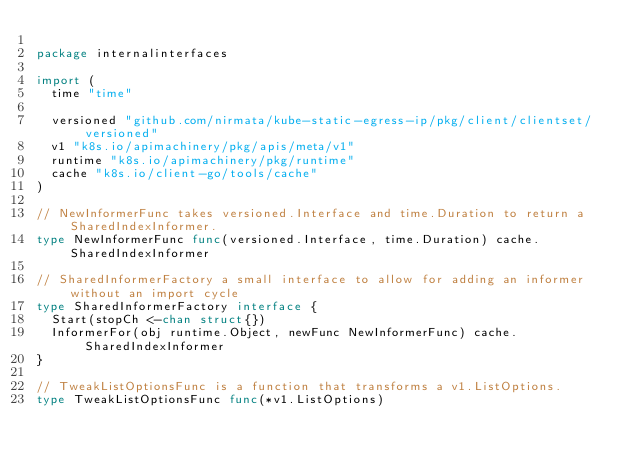Convert code to text. <code><loc_0><loc_0><loc_500><loc_500><_Go_>
package internalinterfaces

import (
	time "time"

	versioned "github.com/nirmata/kube-static-egress-ip/pkg/client/clientset/versioned"
	v1 "k8s.io/apimachinery/pkg/apis/meta/v1"
	runtime "k8s.io/apimachinery/pkg/runtime"
	cache "k8s.io/client-go/tools/cache"
)

// NewInformerFunc takes versioned.Interface and time.Duration to return a SharedIndexInformer.
type NewInformerFunc func(versioned.Interface, time.Duration) cache.SharedIndexInformer

// SharedInformerFactory a small interface to allow for adding an informer without an import cycle
type SharedInformerFactory interface {
	Start(stopCh <-chan struct{})
	InformerFor(obj runtime.Object, newFunc NewInformerFunc) cache.SharedIndexInformer
}

// TweakListOptionsFunc is a function that transforms a v1.ListOptions.
type TweakListOptionsFunc func(*v1.ListOptions)
</code> 